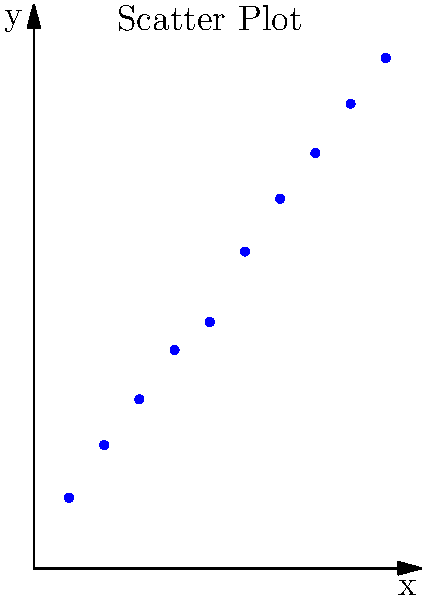As a statistics professor, you're reviewing a student's research project. The student has presented the scatter plot above and claims there is a strong positive correlation between the variables. Based on your expertise, how would you characterize the strength of the correlation, and what advice would you give the student for further analysis? To assess the strength of the correlation and provide advice to the student, we should consider the following steps:

1. Visual inspection:
   The scatter plot shows a clear upward trend, with points generally moving from the bottom-left to the top-right of the graph. This indicates a positive correlation.

2. Linearity:
   The points appear to follow a roughly linear pattern, which supports the use of linear correlation measures.

3. Strength assessment:
   To quantify the strength, we would typically calculate the Pearson correlation coefficient (r). However, without the exact data, we can estimate based on the visual pattern:
   - The points are closely clustered around an imaginary line of best fit.
   - There is little deviation from this line.
   - This suggests a strong positive correlation, likely with r > 0.9.

4. Advice for the student:
   a) Calculate the Pearson correlation coefficient to quantify the strength.
   b) Perform a significance test (e.g., t-test) to determine if the correlation is statistically significant.
   c) Consider calculating the coefficient of determination (r²) to understand the proportion of variance explained by the relationship.
   d) Investigate potential outliers or influential points that might affect the correlation.
   e) Explore the causal relationship between the variables, if applicable to the research question.
   f) Consider other factors that might influence or explain the relationship.

5. Interpretation:
   While the student's claim of a strong positive correlation appears to be correct based on the visual evidence, it's important to support this with numerical evidence and statistical tests.

In conclusion, the scatter plot indeed suggests a strong positive correlation, but formal statistical analysis is necessary to confirm and quantify this observation.
Answer: Strong positive correlation; advise calculating r, performing significance test, and exploring causal relationships. 